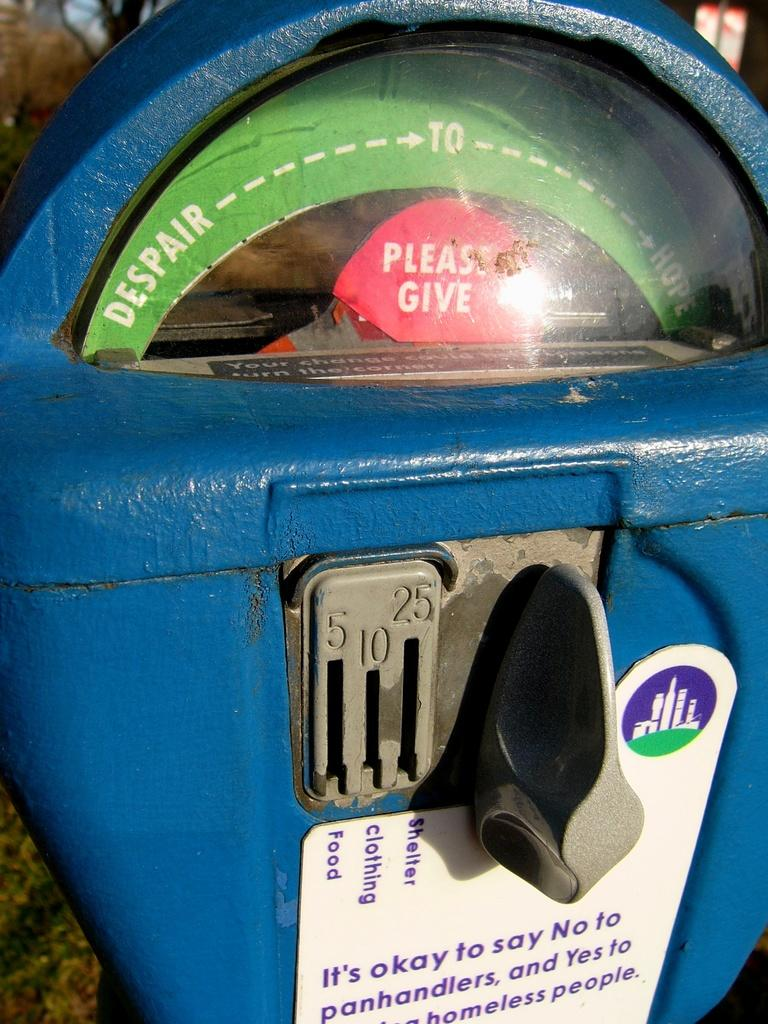<image>
Give a short and clear explanation of the subsequent image. A parking meter has been repurposed for charity aith a pop up that says please give. 